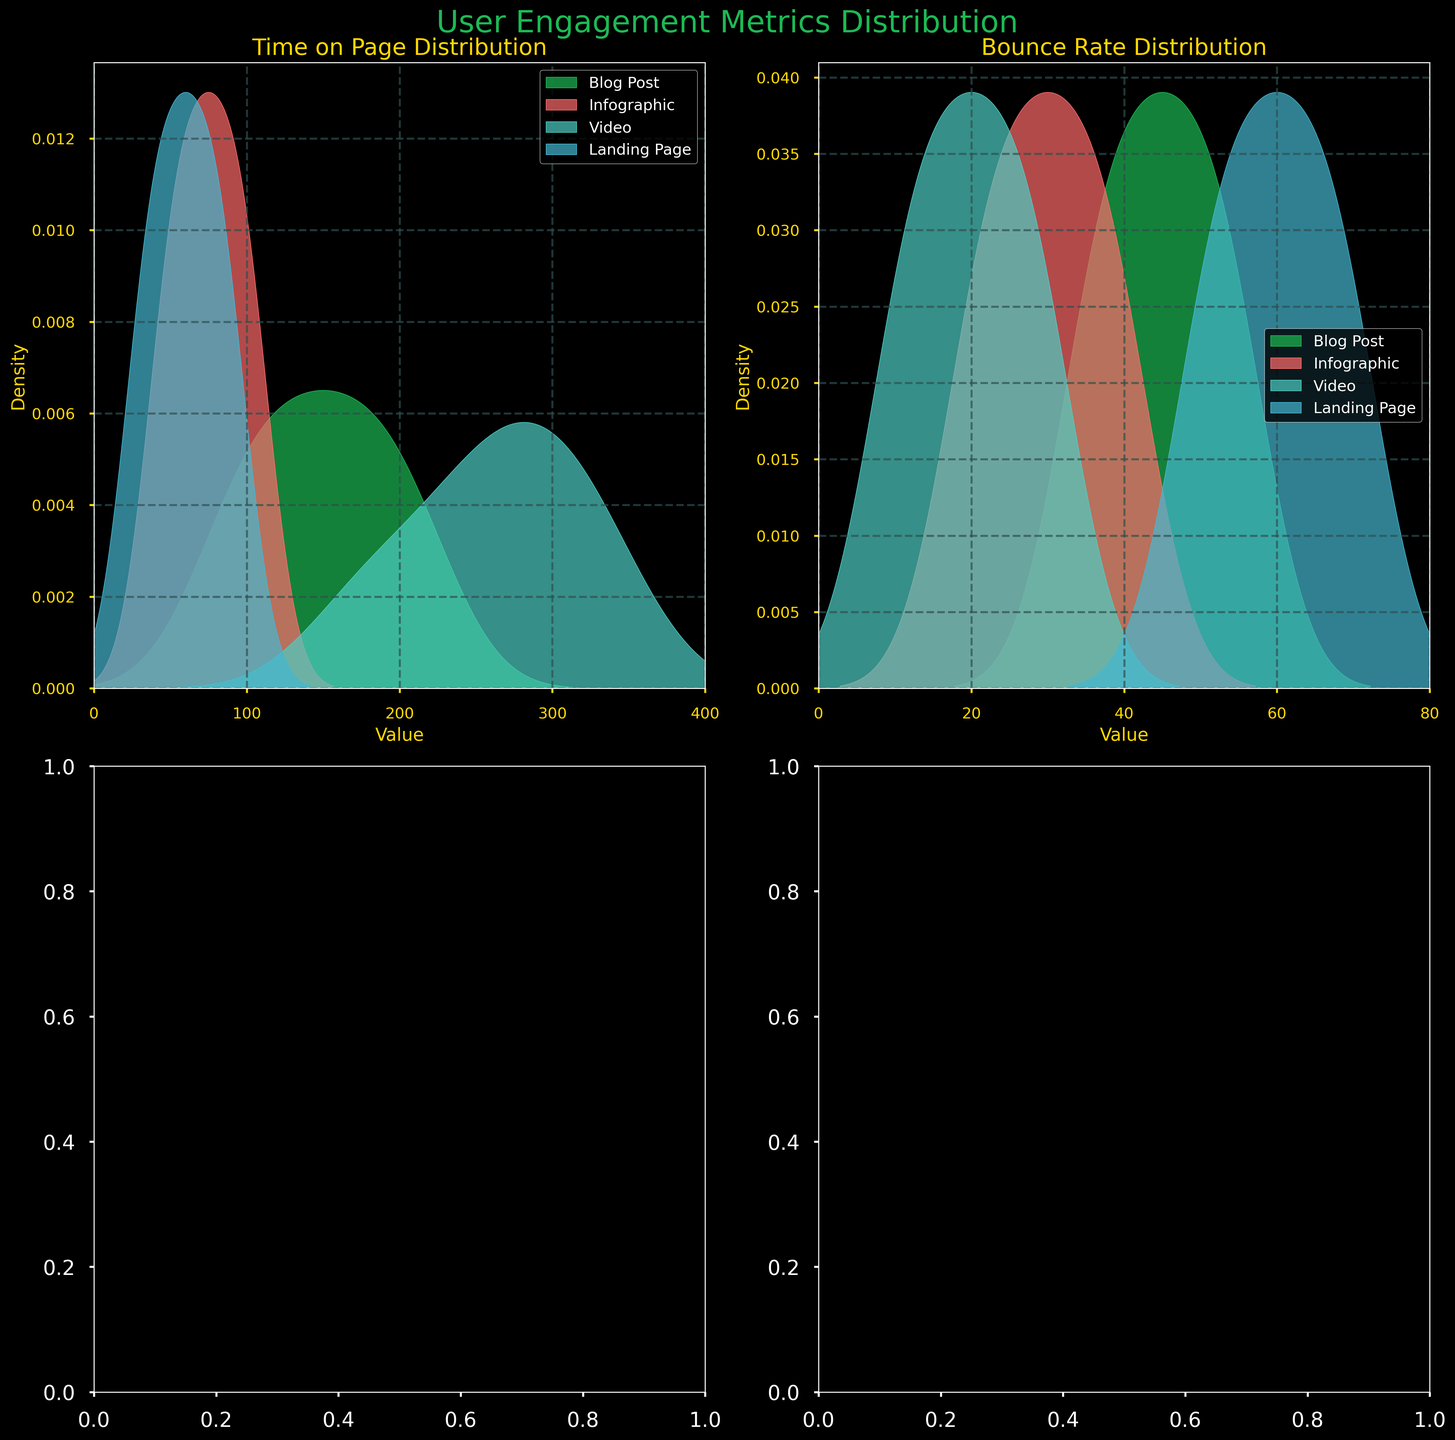What is the title of the figure? The title of the figure is displayed at the top and reads "User Engagement Metrics Distribution"
Answer: User Engagement Metrics Distribution What are the content types displayed in the figure? Each density plot in the figure has a legend that shows the content types, which are "Blog Post," "Infographic," "Video," and "Landing Page"
Answer: Blog Post, Infographic, Video, Landing Page Which content type has the highest density in Time on Page? By examining the density peaks in the Time on Page plots, the "Video" content type has the highest density peak
Answer: Video What's the bounce rate distribution like for Infographics compared to Landing Pages? By comparing the density plots for the bounce rate, the peak densities for Infographics are generally lower and occur at lower values compared to Landing Pages
Answer: Lower and at lower values What is the range of values for the Time on Page metric? The x-axis in the Time on Page plots shows the range from 0 to 400 seconds
Answer: 0 to 400 seconds Which metric has the wider distribution, Time on Page or Bounce Rate? Time on Page has a wider range from 0-400 seconds, whereas Bounce Rate ranges from 0-80, indicating a wider distribution for the Time on Page metric
Answer: Time on Page How does the density peak of the bounce rate for Blog Posts compare to that of Videos? The density peak for the bounce rate of Blog Posts is higher and occurs at higher values compared to Videos, which have lower and earlier peaks
Answer: Blog Posts have higher and later peaks What content type shows the lowest bounce rate? From the density plots for the bounce rate, Videos show the lowest bounce rates peaking around 10-30 values
Answer: Videos How do the Time on Page densities for Blog Posts and Infographics compare? Examining the Time on Page density plots, Blog Posts have density peaks at higher values (around 120-210) compared to Infographics (45-105)
Answer: Blog Posts have higher peaks 